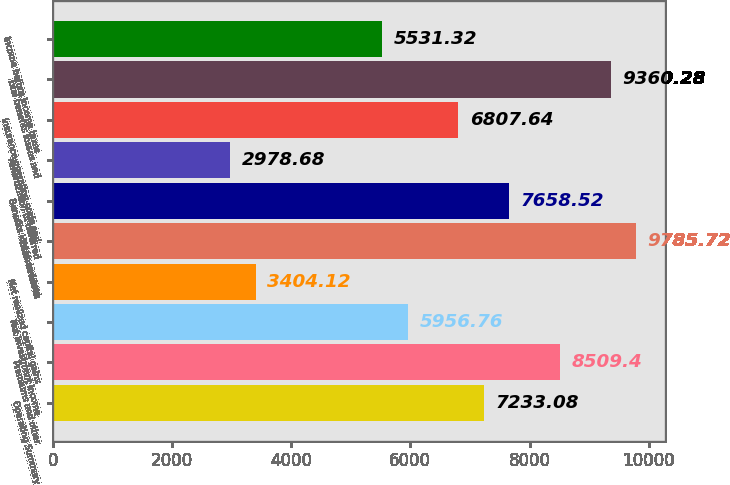Convert chart to OTSL. <chart><loc_0><loc_0><loc_500><loc_500><bar_chart><fcel>Operating Summary<fcel>Premiums and other<fcel>Net investment income<fcel>Net realized capital gains<fcel>Total revenues<fcel>Benefits losses and loss<fcel>Amortization of deferred<fcel>Insurance operating costs and<fcel>Total benefits losses and<fcel>Income before income taxes<nl><fcel>7233.08<fcel>8509.4<fcel>5956.76<fcel>3404.12<fcel>9785.72<fcel>7658.52<fcel>2978.68<fcel>6807.64<fcel>9360.28<fcel>5531.32<nl></chart> 